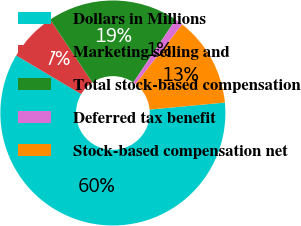Convert chart to OTSL. <chart><loc_0><loc_0><loc_500><loc_500><pie_chart><fcel>Dollars in Millions<fcel>Marketing selling and<fcel>Total stock-based compensation<fcel>Deferred tax benefit<fcel>Stock-based compensation net<nl><fcel>60.02%<fcel>7.05%<fcel>18.82%<fcel>1.17%<fcel>12.94%<nl></chart> 